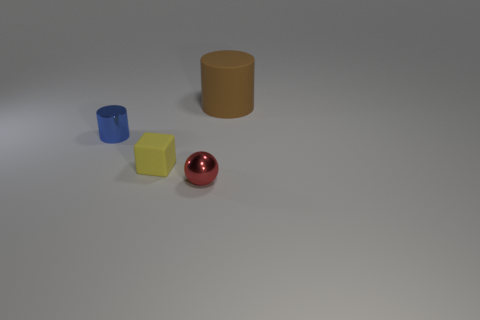How many other things are the same shape as the brown object?
Ensure brevity in your answer.  1. There is a big matte object; is its shape the same as the object that is in front of the yellow cube?
Ensure brevity in your answer.  No. There is a small matte block; what number of yellow matte objects are to the left of it?
Provide a short and direct response. 0. Are there any other things that are made of the same material as the tiny sphere?
Keep it short and to the point. Yes. There is a metal object that is to the right of the tiny shiny cylinder; is it the same shape as the yellow matte thing?
Provide a short and direct response. No. There is a matte object that is to the right of the small shiny sphere; what is its color?
Provide a short and direct response. Brown. There is a red object that is the same material as the small blue cylinder; what shape is it?
Make the answer very short. Sphere. Is there anything else that has the same color as the big thing?
Your response must be concise. No. Are there more cylinders that are in front of the rubber cylinder than large matte cylinders that are on the left side of the metallic cylinder?
Make the answer very short. Yes. How many blue shiny cylinders are the same size as the yellow rubber thing?
Offer a very short reply. 1. 